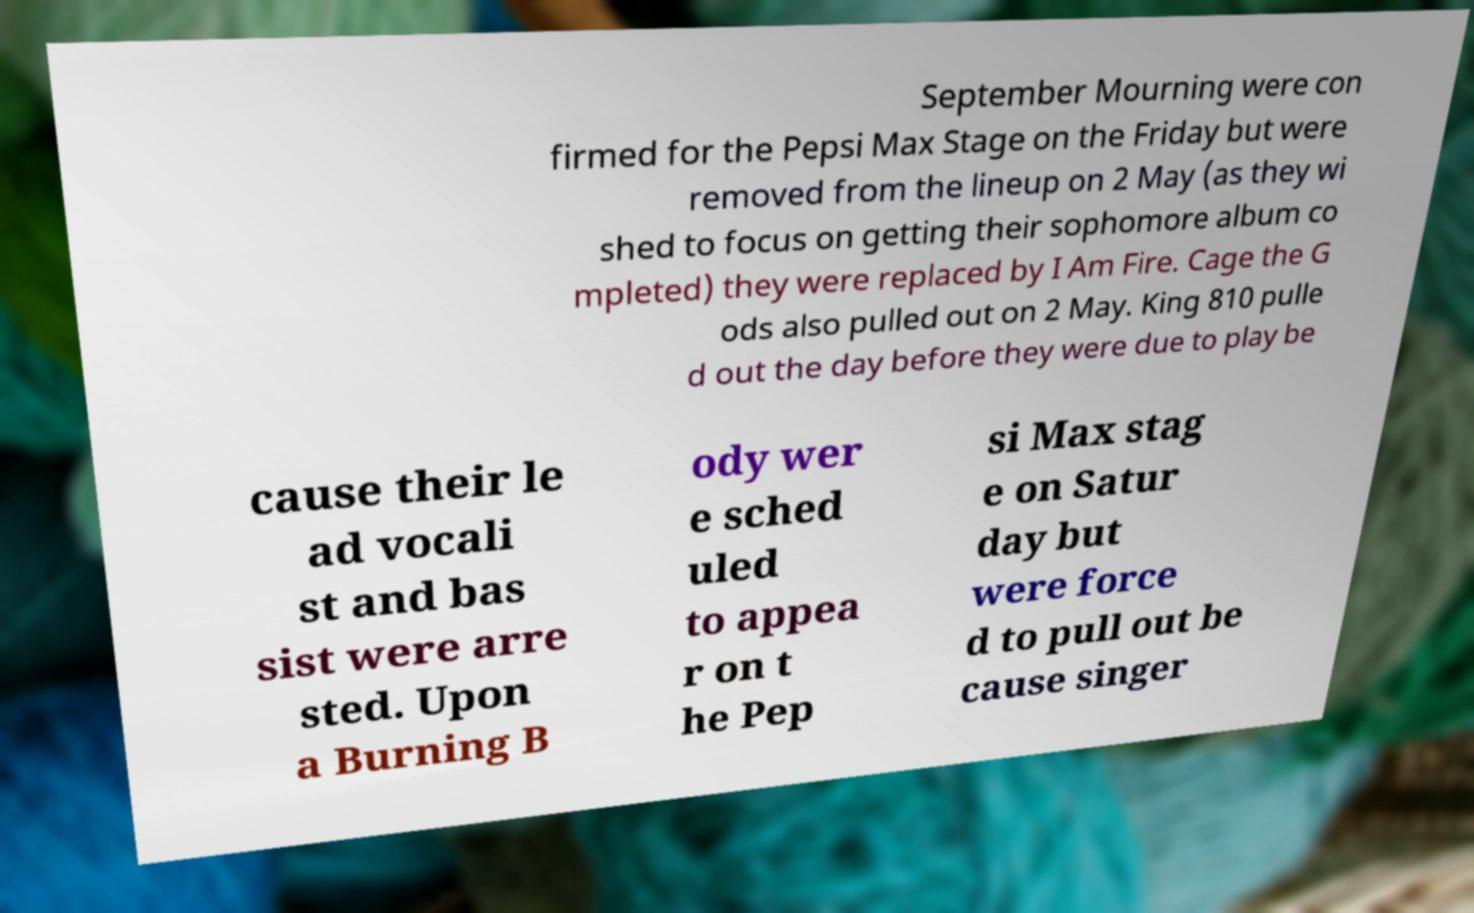Can you read and provide the text displayed in the image?This photo seems to have some interesting text. Can you extract and type it out for me? September Mourning were con firmed for the Pepsi Max Stage on the Friday but were removed from the lineup on 2 May (as they wi shed to focus on getting their sophomore album co mpleted) they were replaced by I Am Fire. Cage the G ods also pulled out on 2 May. King 810 pulle d out the day before they were due to play be cause their le ad vocali st and bas sist were arre sted. Upon a Burning B ody wer e sched uled to appea r on t he Pep si Max stag e on Satur day but were force d to pull out be cause singer 